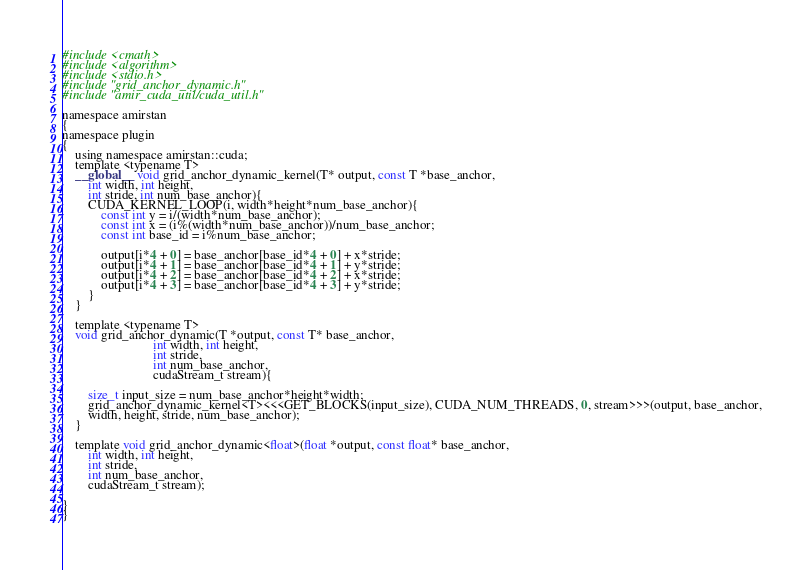<code> <loc_0><loc_0><loc_500><loc_500><_Cuda_>#include <cmath>
#include <algorithm>
#include <stdio.h>
#include "grid_anchor_dynamic.h"
#include "amir_cuda_util/cuda_util.h"

namespace amirstan
{
namespace plugin
{
    using namespace amirstan::cuda;
    template <typename T>
    __global__ void grid_anchor_dynamic_kernel(T* output, const T *base_anchor, 
        int width, int height,
        int stride, int num_base_anchor){
        CUDA_KERNEL_LOOP(i, width*height*num_base_anchor){
            const int y = i/(width*num_base_anchor);
            const int x = (i%(width*num_base_anchor))/num_base_anchor;
            const int base_id = i%num_base_anchor;

            output[i*4 + 0] = base_anchor[base_id*4 + 0] + x*stride;
            output[i*4 + 1] = base_anchor[base_id*4 + 1] + y*stride;
            output[i*4 + 2] = base_anchor[base_id*4 + 2] + x*stride;
            output[i*4 + 3] = base_anchor[base_id*4 + 3] + y*stride;
        }
    }

    template <typename T>
    void grid_anchor_dynamic(T *output, const T* base_anchor, 
                            int width, int height, 
                            int stride,
                            int num_base_anchor,
                            cudaStream_t stream){
        
        size_t input_size = num_base_anchor*height*width;
        grid_anchor_dynamic_kernel<T><<<GET_BLOCKS(input_size), CUDA_NUM_THREADS, 0, stream>>>(output, base_anchor,
        width, height, stride, num_base_anchor);
    }

    template void grid_anchor_dynamic<float>(float *output, const float* base_anchor, 
        int width, int height, 
        int stride,
        int num_base_anchor,
        cudaStream_t stream);

}
}</code> 